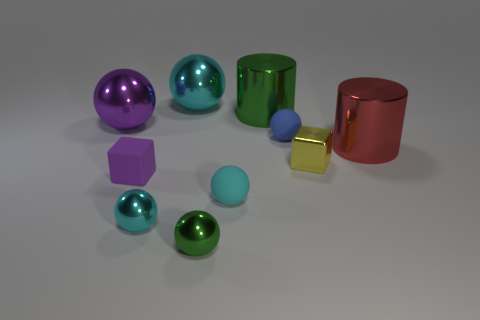Subtract all green cylinders. How many cyan spheres are left? 3 Subtract all small cyan metal balls. How many balls are left? 5 Subtract all blue spheres. How many spheres are left? 5 Subtract all gray balls. Subtract all cyan cylinders. How many balls are left? 6 Subtract all spheres. How many objects are left? 4 Subtract all tiny metal cubes. Subtract all yellow shiny cubes. How many objects are left? 8 Add 9 blue spheres. How many blue spheres are left? 10 Add 2 big blue shiny blocks. How many big blue shiny blocks exist? 2 Subtract 0 brown balls. How many objects are left? 10 